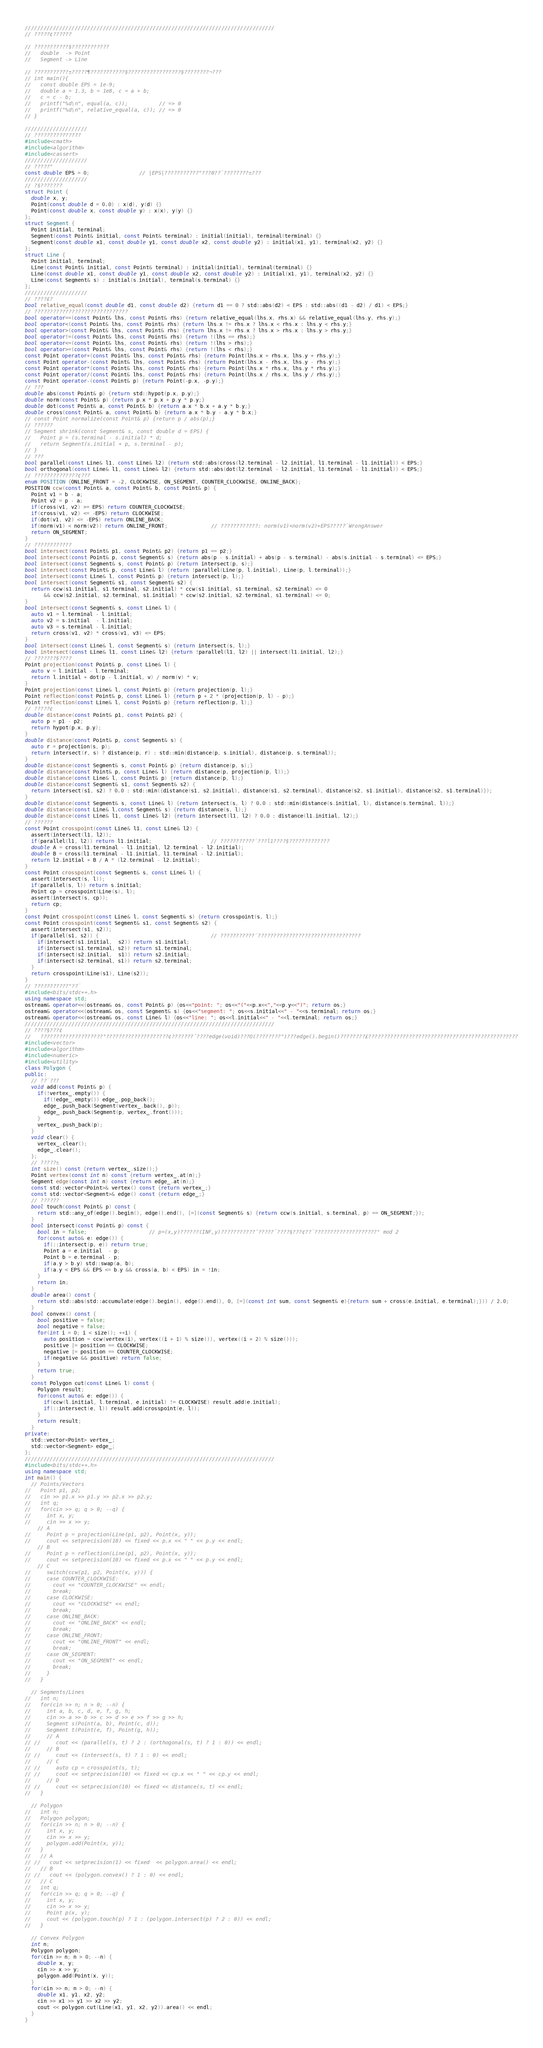Convert code to text. <code><loc_0><loc_0><loc_500><loc_500><_C++_>////////////////////////////////////////////////////////////////////////////////
// ?????¢??????

// ???????????§????????????
//   double  -> Point
//   Segment -> Line

// ???????????±?????¶???????????§?????????????????§????????¬???
// int main(){
//   const double EPS = 1e-9;
//   double a = 1.3, b = 1e8, c = a + b;
//   c = c - b;
//   printf("%d\n", equal(a, c));          // => 0
//   printf("%d\n", relative_equal(a, c)); // => 0
// }

////////////////////
// ???????????????
#include<cmath>
#include<algorithm>
#include<cassert>
////////////////////
// ?????°
const double EPS = 0;                // |EPS|???????????°???0??¨????????±???
////////////////////
// ?§???????
struct Point {
  double x, y;
  Point(const double d = 0.0) : x(d), y(d) {}
  Point(const double x, const double y) : x(x), y(y) {}
};
struct Segment {
  Point initial, terminal;
  Segment(const Point& initial, const Point& terminal) : initial(initial), terminal(terminal) {}
  Segment(const double x1, const double y1, const double x2, const double y2) : initial(x1, y1), terminal(x2, y2) {}
};
struct Line {
  Point initial, terminal;
  Line(const Point& initial, const Point& terminal) : initial(initial), terminal(terminal) {}
  Line(const double x1, const double y1, const double x2, const double y2) : initial(x1, y1), terminal(x2, y2) {}
  Line(const Segment& s) : initial(s.initial), terminal(s.terminal) {}
};
////////////////////
// ????£?
bool relative_equal(const double d1, const double d2) {return d1 == 0 ? std::abs(d2) < EPS : std::abs((d1 - d2) / d1) < EPS;}
// ??????????????????????????????
bool operator==(const Point& lhs, const Point& rhs) {return relative_equal(lhs.x, rhs.x) && relative_equal(lhs.y, rhs.y);}
bool operator<(const Point& lhs, const Point& rhs) {return lhs.x != rhs.x ? lhs.x < rhs.x : lhs.y < rhs.y;}
bool operator>(const Point& lhs, const Point& rhs) {return lhs.x != rhs.x ? lhs.x > rhs.x : lhs.y > rhs.y;}
bool operator!=(const Point& lhs, const Point& rhs) {return !(lhs == rhs);}
bool operator<=(const Point& lhs, const Point& rhs) {return !(lhs > rhs);}
bool operator>=(const Point& lhs, const Point& rhs) {return !(lhs < rhs);}
const Point operator+(const Point& lhs, const Point& rhs) {return Point(lhs.x + rhs.x, lhs.y + rhs.y);}
const Point operator-(const Point& lhs, const Point& rhs) {return Point(lhs.x - rhs.x, lhs.y - rhs.y);}
const Point operator*(const Point& lhs, const Point& rhs) {return Point(lhs.x * rhs.x, lhs.y * rhs.y);}
const Point operator/(const Point& lhs, const Point& rhs) {return Point(lhs.x / rhs.x, lhs.y / rhs.y);}
const Point operator-(const Point& p) {return Point(-p.x, -p.y);}
// ???
double abs(const Point& p) {return std::hypot(p.x, p.y);}
double norm(const Point& p) {return p.x * p.x + p.y * p.y;}
double dot(const Point& a, const Point& b) {return a.x * b.x + a.y * b.y;}
double cross(const Point& a, const Point& b) {return a.x * b.y - a.y * b.x;}
// const Point normalize(const Point& p) {return p / abs(p);}
// ??????
// Segment shrink(const Segment& s, const double d = EPS) {
//   Point p = (s.terminal - s.initial) * d;
//   return Segment(s.initial + p, s.terminal - p);
// }
// ???
bool parallel(const Line& l1, const Line& l2) {return std::abs(cross(l2.terminal - l2.initial, l1.terminal - l1.initial)) < EPS;}
bool orthogonal(const Line& l1, const Line& l2) {return std::abs(dot(l2.terminal - l2.initial, l1.terminal - l1.initial)) < EPS;}
// ??????????????¢???
enum POSITION {ONLINE_FRONT = -2, CLOCKWISE, ON_SEGMENT, COUNTER_CLOCKWISE, ONLINE_BACK}; 
POSITION ccw(const Point& a, const Point& b, const Point& p) {
  Point v1 = b - a;
  Point v2 = p - a;
  if(cross(v1, v2) >= EPS) return COUNTER_CLOCKWISE;
  if(cross(v1, v2) <= -EPS) return CLOCKWISE;
  if(dot(v1, v2) <= -EPS) return ONLINE_BACK;
  if(norm(v1) < norm(v2)) return ONLINE_FRONT;              // ????????????: norm(v1)<norm(v2)+EPS?????¨WrongAnswer
  return ON_SEGMENT;
}
// ????????????
bool intersect(const Point& p1, const Point& p2) {return p1 == p2;}
bool intersect(const Point& p, const Segment& s) {return abs(p - s.initial) + abs(p - s.terminal) - abs(s.initial - s.terminal) <= EPS;}
bool intersect(const Segment& s, const Point& p) {return intersect(p, s);}
bool intersect(const Point& p, const Line& l) {return !parallel(Line(p, l.initial), Line(p, l.terminal));}
bool intersect(const Line& l, const Point& p) {return intersect(p, l);}
bool intersect(const Segment& s1, const Segment& s2) {
  return ccw(s1.initial, s1.terminal, s2.initial) * ccw(s1.initial, s1.terminal, s2.terminal) <= 0
      && ccw(s2.initial, s2.terminal, s1.initial) * ccw(s2.initial, s2.terminal, s1.terminal) <= 0;
}
bool intersect(const Segment& s, const Line& l) {
  auto v1 = l.terminal - l.initial;
  auto v2 = s.initial  - l.initial;
  auto v3 = s.terminal - l.initial;
  return cross(v1, v2) * cross(v1, v3) <= EPS;
}
bool intersect(const Line& l, const Segment& s) {return intersect(s, l);}
bool intersect(const Line& l1, const Line& l2) {return !parallel(l1, l2) || intersect(l1.initial, l2);}
// ???????§????
Point projection(const Point& p, const Line& l) {
  auto v = l.initial - l.terminal;
  return l.initial + dot(p - l.initial, v) / norm(v) * v;
}
Point projection(const Line& l, const Point& p) {return projection(p, l);}
Point reflection(const Point& p, const Line& l) {return p + 2 * (projection(p, l) - p);}
Point reflection(const Line& l, const Point& p) {return reflection(p, l);}
// ?????¢
double distance(const Point& p1, const Point& p2) {
  auto p = p1 - p2;
  return hypot(p.x, p.y);
}
double distance(const Point& p, const Segment& s) {
  auto r = projection(s, p);
  return intersect(r, s) ? distance(p, r) : std::min(distance(p, s.initial), distance(p, s.terminal));
}
double distance(const Segment& s, const Point& p) {return distance(p, s);}
double distance(const Point& p, const Line& l) {return distance(p, projection(p, l));}
double distance(const Line& l, const Point& p) {return distance(p, l);}
double distance(const Segment& s1, const Segment& s2) {
  return intersect(s1, s2) ? 0.0 : std::min({distance(s1, s2.initial), distance(s1, s2.terminal), distance(s2, s1.initial), distance(s2, s1.terminal)});
}
double distance(const Segment& s, const Line& l) {return intersect(s, l) ? 0.0 : std::min(distance(s.initial, l), distance(s.terminal, l));}
double distance(const Line& l,const Segment& s) {return distance(s, l);}
double distance(const Line& l1, const Line& l2) {return intersect(l1, l2) ? 0.0 : distance(l1.initial, l2);}
// ??????
const Point crosspoint(const Line& l1, const Line& l2) {
  assert(intersect(l1, l2));
  if(parallel(l1, l2)) return l1.initial;                   // ???????????¨???l1????§?????????????
  double A = cross(l1.terminal - l1.initial, l2.terminal - l2.initial);
  double B = cross(l1.terminal - l1.initial, l1.terminal - l2.initial);
  return l2.initial + B / A * (l2.terminal - l2.initial);
}
const Point crosspoint(const Segment& s, const Line& l) {
  assert(intersect(s, l));
  if(parallel(s, l)) return s.initial;
  Point cp = crosspoint(Line(s), l);
  assert(intersect(s, cp));
  return cp;
}
const Point crosspoint(const Line& l, const Segment& s) {return crosspoint(s, l);}
const Point crosspoint(const Segment& s1, const Segment& s2) {
  assert(intersect(s1, s2));
  if(parallel(s1, s2)) {                                    // ???????????¨?????????????????????????????????
    if(intersect(s1.initial,  s2)) return s1.initial;
    if(intersect(s1.terminal, s2)) return s1.terminal;
    if(intersect(s2.initial,  s1)) return s2.initial;
    if(intersect(s2.terminal, s1)) return s2.terminal;
  }
  return crosspoint(Line(s1), Line(s2));
}
// ???????????°??¨
#include<bits/stdc++.h>
using namespace std;
ostream& operator<<(ostream& os, const Point& p) {os<<"point: "; os<<"("<<p.x<<","<<p.y<<")"; return os;}
ostream& operator<<(ostream& os, const Segment& s) {os<<"segment: "; os<<s.initial<<" - "<<s.terminal; return os;}
ostream& operator<<(ostream& os, const Line& l) {os<<"line: "; os<<l.initial<<" - "<<l.terminal; return os;}
////////////////////////////////////////////////////////////////////////////////
// ????§???¢
//   ????????????????????°????????????????????¢???????´????edge(void)???O(????????°)???edge().begin()????????£????????????????????????????????????????????????
#include<vector>
#include<algorithm>
#include<numeric>
#include<utility>
class Polygon {
public:
  // ??¨???
  void add(const Point& p) {
    if(!vertex_.empty()) {
      if(!edge_.empty()) edge_.pop_back();
      edge_.push_back(Segment(vertex_.back(), p));
      edge_.push_back(Segment(p, vertex_.front()));
    }
    vertex_.push_back(p);
  }
  void clear() {
    vertex_.clear();
    edge_.clear();
  };
  // ?????±
  int size() const {return vertex_.size();}
  Point vertex(const int n) const {return vertex_.at(n);}
  Segment edge(const int n) const {return edge_.at(n);}
  const std::vector<Point>& vertex() const {return vertex_;}
  const std::vector<Segment>& edge() const {return edge_;}
  // ??????
  bool touch(const Point& p) const {
    return std::any_of(edge().begin(), edge().end(), [=](const Segment& s) {return ccw(s.initial, s.terminal, p) == ON_SEGMENT;});
  }
  bool intersect(const Point& p) const {
    bool in = false;                    // p=(x,y)??????(INF,y)???????????´?????¨????§???¢??¨????????????????????° mod 2
    for(const auto& e: edge()) {
      if(::intersect(p, e)) return true;
      Point a = e.initial  - p;
      Point b = e.terminal - p;
      if(a.y > b.y) std::swap(a, b);
      if(a.y < EPS && EPS <= b.y && cross(a, b) < EPS) in = !in;
    }
    return in;
  }
  double area() const {
    return std::abs(std::accumulate(edge().begin(), edge().end(), 0, [=](const int sum, const Segment& e){return sum + cross(e.initial, e.terminal);})) / 2.0;
  }
  bool convex() const {
    bool positive = false;
    bool negative = false;
    for(int i = 0; i < size(); ++i) {
      auto position = ccw(vertex(i), vertex((i + 1) % size()), vertex((i + 2) % size()));
      positive |= position == CLOCKWISE;
      negative |= position == COUNTER_CLOCKWISE;
      if(negative && positive) return false;
    }
    return true;
  }
  const Polygon cut(const Line& l) const {
    Polygon result;
    for(const auto& e: edge()) {
      if(ccw(l.initial, l.terminal, e.initial) != CLOCKWISE) result.add(e.initial);
      if(::intersect(e, l)) result.add(crosspoint(e, l));
    }
    return result;
  }
private:
  std::vector<Point> vertex_;
  std::vector<Segment> edge_;
};
////////////////////////////////////////////////////////////////////////////////
#include<bits/stdc++.h>
using namespace std;
int main() {
  // Points/Vectors
//   Point p1, p2;
//   cin >> p1.x >> p1.y >> p2.x >> p2.y;
//   int q;
//   for(cin >> q; q > 0; --q) {
//     int x, y;
//     cin >> x >> y;
    // A
//     Point p = projection(Line(p1, p2), Point(x, y));
//     cout << setprecision(10) << fixed << p.x << " " << p.y << endl;
    // B
//     Point p = reflection(Line(p1, p2), Point(x, y));
//     cout << setprecision(10) << fixed << p.x << " " << p.y << endl;
    // C
//     switch(ccw(p1, p2, Point(x, y))) {
//     case COUNTER_CLOCKWISE:
//       cout << "COUNTER_CLOCKWISE" << endl;
//       break;
//     case CLOCKWISE:
//       cout << "CLOCKWISE" << endl;
//       break;
//     case ONLINE_BACK:
//       cout << "ONLINE_BACK" << endl;
//       break;
//     case ONLINE_FRONT:
//       cout << "ONLINE_FRONT" << endl;
//       break;
//     case ON_SEGMENT:
//       cout << "ON_SEGMENT" << endl;
//       break;
//     }
//   }

  // Segments/Lines
//   int n;
//   for(cin >> n; n > 0; --n) {
//     int a, b, c, d, e, f, g, h;
//     cin >> a >> b >> c >> d >> e >> f >> g >> h;
//     Segment s(Point(a, b), Point(c, d));
//     Segment t(Point(e, f), Point(g, h));
//     // A
// //     cout << (parallel(s, t) ? 2 : (orthogonal(s, t) ? 1 : 0)) << endl;
//     // B
// //     cout << (intersect(s, t) ? 1 : 0) << endl;
//     // C
// //     auto cp = crosspoint(s, t);
// //     cout << setprecision(10) << fixed << cp.x << " " << cp.y << endl;
//     // D
// //     cout << setprecision(10) << fixed << distance(s, t) << endl;
//   }

  // Polygon
//   int n;
//   Polygon polygon;
//   for(cin >> n; n > 0; --n) {
//     int x, y;
//     cin >> x >> y;
//     polygon.add(Point(x, y));
//   }
//   // A
// //   cout << setprecision(1) << fixed  << polygon.area() << endl;
//   // B
// //   cout << (polygon.convex() ? 1 : 0) << endl;
//   // C
//   int q;
//   for(cin >> q; q > 0; --q) {
//     int x, y;
//     cin >> x >> y;
//     Point p(x, y);
//     cout << (polygon.touch(p) ? 1 : (polygon.intersect(p) ? 2 : 0)) << endl;
//   }

  // Convex Polygon
  int n;
  Polygon polygon;
  for(cin >> n; n > 0; --n) {
    double x, y;
    cin >> x >> y;
    polygon.add(Point(x, y));
  }
  for(cin >> n; n > 0; --n) {
    double x1, y1, x2, y2;
    cin >> x1 >> y1 >> x2 >> y2;
    cout << polygon.cut(Line(x1, y1, x2, y2)).area() << endl;
  }
}</code> 